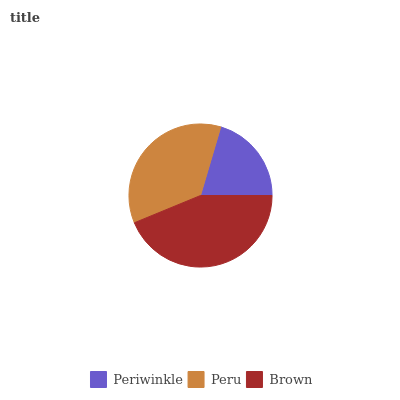Is Periwinkle the minimum?
Answer yes or no. Yes. Is Brown the maximum?
Answer yes or no. Yes. Is Peru the minimum?
Answer yes or no. No. Is Peru the maximum?
Answer yes or no. No. Is Peru greater than Periwinkle?
Answer yes or no. Yes. Is Periwinkle less than Peru?
Answer yes or no. Yes. Is Periwinkle greater than Peru?
Answer yes or no. No. Is Peru less than Periwinkle?
Answer yes or no. No. Is Peru the high median?
Answer yes or no. Yes. Is Peru the low median?
Answer yes or no. Yes. Is Brown the high median?
Answer yes or no. No. Is Brown the low median?
Answer yes or no. No. 